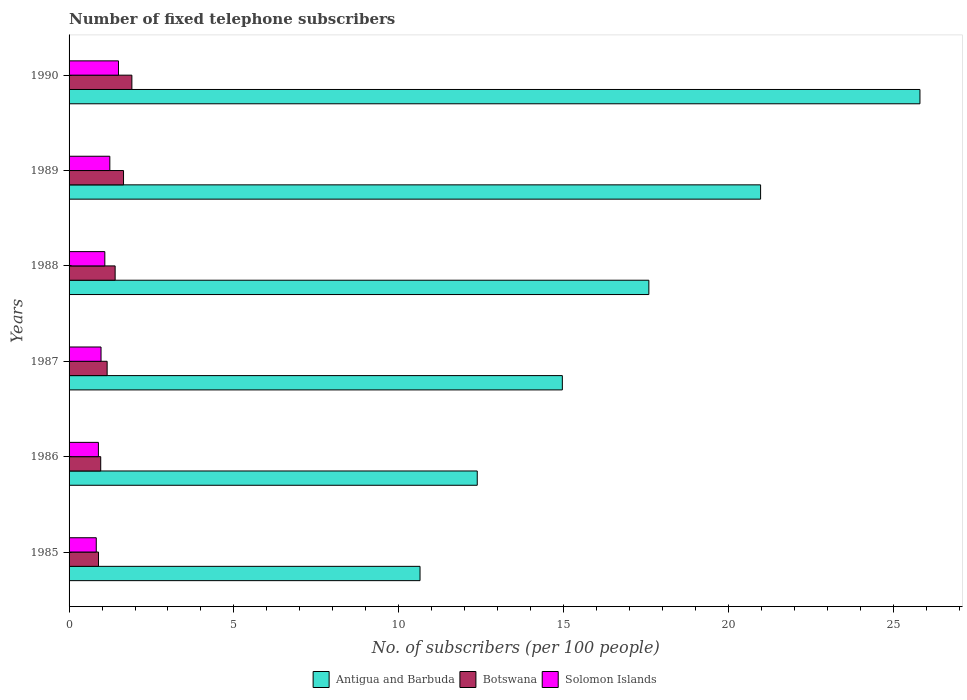How many different coloured bars are there?
Give a very brief answer. 3. How many groups of bars are there?
Your answer should be compact. 6. How many bars are there on the 5th tick from the top?
Your answer should be compact. 3. What is the label of the 4th group of bars from the top?
Your response must be concise. 1987. What is the number of fixed telephone subscribers in Botswana in 1990?
Provide a succinct answer. 1.91. Across all years, what is the maximum number of fixed telephone subscribers in Solomon Islands?
Offer a very short reply. 1.5. Across all years, what is the minimum number of fixed telephone subscribers in Solomon Islands?
Make the answer very short. 0.82. In which year was the number of fixed telephone subscribers in Solomon Islands maximum?
Ensure brevity in your answer.  1990. What is the total number of fixed telephone subscribers in Solomon Islands in the graph?
Keep it short and to the point. 6.51. What is the difference between the number of fixed telephone subscribers in Botswana in 1989 and that in 1990?
Provide a succinct answer. -0.25. What is the difference between the number of fixed telephone subscribers in Solomon Islands in 1987 and the number of fixed telephone subscribers in Botswana in 1985?
Your answer should be compact. 0.08. What is the average number of fixed telephone subscribers in Botswana per year?
Your response must be concise. 1.33. In the year 1985, what is the difference between the number of fixed telephone subscribers in Botswana and number of fixed telephone subscribers in Antigua and Barbuda?
Offer a terse response. -9.75. What is the ratio of the number of fixed telephone subscribers in Antigua and Barbuda in 1988 to that in 1990?
Provide a short and direct response. 0.68. What is the difference between the highest and the second highest number of fixed telephone subscribers in Solomon Islands?
Give a very brief answer. 0.26. What is the difference between the highest and the lowest number of fixed telephone subscribers in Antigua and Barbuda?
Offer a very short reply. 15.17. In how many years, is the number of fixed telephone subscribers in Botswana greater than the average number of fixed telephone subscribers in Botswana taken over all years?
Make the answer very short. 3. What does the 3rd bar from the top in 1986 represents?
Your answer should be compact. Antigua and Barbuda. What does the 2nd bar from the bottom in 1990 represents?
Provide a succinct answer. Botswana. Is it the case that in every year, the sum of the number of fixed telephone subscribers in Antigua and Barbuda and number of fixed telephone subscribers in Botswana is greater than the number of fixed telephone subscribers in Solomon Islands?
Make the answer very short. Yes. How many bars are there?
Keep it short and to the point. 18. How many years are there in the graph?
Your response must be concise. 6. Are the values on the major ticks of X-axis written in scientific E-notation?
Your answer should be compact. No. Where does the legend appear in the graph?
Offer a very short reply. Bottom center. How many legend labels are there?
Your response must be concise. 3. How are the legend labels stacked?
Your answer should be very brief. Horizontal. What is the title of the graph?
Make the answer very short. Number of fixed telephone subscribers. Does "Luxembourg" appear as one of the legend labels in the graph?
Keep it short and to the point. No. What is the label or title of the X-axis?
Your answer should be compact. No. of subscribers (per 100 people). What is the label or title of the Y-axis?
Offer a terse response. Years. What is the No. of subscribers (per 100 people) in Antigua and Barbuda in 1985?
Give a very brief answer. 10.65. What is the No. of subscribers (per 100 people) of Botswana in 1985?
Offer a terse response. 0.89. What is the No. of subscribers (per 100 people) of Solomon Islands in 1985?
Your response must be concise. 0.82. What is the No. of subscribers (per 100 people) in Antigua and Barbuda in 1986?
Provide a succinct answer. 12.38. What is the No. of subscribers (per 100 people) in Botswana in 1986?
Ensure brevity in your answer.  0.96. What is the No. of subscribers (per 100 people) of Solomon Islands in 1986?
Provide a short and direct response. 0.89. What is the No. of subscribers (per 100 people) in Antigua and Barbuda in 1987?
Your answer should be very brief. 14.96. What is the No. of subscribers (per 100 people) of Botswana in 1987?
Provide a succinct answer. 1.16. What is the No. of subscribers (per 100 people) of Solomon Islands in 1987?
Offer a very short reply. 0.97. What is the No. of subscribers (per 100 people) of Antigua and Barbuda in 1988?
Offer a very short reply. 17.59. What is the No. of subscribers (per 100 people) of Botswana in 1988?
Provide a short and direct response. 1.4. What is the No. of subscribers (per 100 people) of Solomon Islands in 1988?
Give a very brief answer. 1.08. What is the No. of subscribers (per 100 people) of Antigua and Barbuda in 1989?
Provide a succinct answer. 20.98. What is the No. of subscribers (per 100 people) in Botswana in 1989?
Make the answer very short. 1.65. What is the No. of subscribers (per 100 people) of Solomon Islands in 1989?
Your response must be concise. 1.24. What is the No. of subscribers (per 100 people) in Antigua and Barbuda in 1990?
Provide a short and direct response. 25.81. What is the No. of subscribers (per 100 people) in Botswana in 1990?
Make the answer very short. 1.91. What is the No. of subscribers (per 100 people) of Solomon Islands in 1990?
Offer a very short reply. 1.5. Across all years, what is the maximum No. of subscribers (per 100 people) of Antigua and Barbuda?
Your response must be concise. 25.81. Across all years, what is the maximum No. of subscribers (per 100 people) of Botswana?
Your answer should be compact. 1.91. Across all years, what is the maximum No. of subscribers (per 100 people) of Solomon Islands?
Your response must be concise. 1.5. Across all years, what is the minimum No. of subscribers (per 100 people) in Antigua and Barbuda?
Offer a very short reply. 10.65. Across all years, what is the minimum No. of subscribers (per 100 people) in Botswana?
Your response must be concise. 0.89. Across all years, what is the minimum No. of subscribers (per 100 people) of Solomon Islands?
Give a very brief answer. 0.82. What is the total No. of subscribers (per 100 people) in Antigua and Barbuda in the graph?
Your answer should be compact. 102.38. What is the total No. of subscribers (per 100 people) in Botswana in the graph?
Ensure brevity in your answer.  7.96. What is the total No. of subscribers (per 100 people) in Solomon Islands in the graph?
Give a very brief answer. 6.51. What is the difference between the No. of subscribers (per 100 people) of Antigua and Barbuda in 1985 and that in 1986?
Your answer should be very brief. -1.74. What is the difference between the No. of subscribers (per 100 people) of Botswana in 1985 and that in 1986?
Your answer should be very brief. -0.07. What is the difference between the No. of subscribers (per 100 people) of Solomon Islands in 1985 and that in 1986?
Your answer should be very brief. -0.07. What is the difference between the No. of subscribers (per 100 people) in Antigua and Barbuda in 1985 and that in 1987?
Give a very brief answer. -4.32. What is the difference between the No. of subscribers (per 100 people) of Botswana in 1985 and that in 1987?
Provide a short and direct response. -0.26. What is the difference between the No. of subscribers (per 100 people) of Solomon Islands in 1985 and that in 1987?
Offer a terse response. -0.14. What is the difference between the No. of subscribers (per 100 people) in Antigua and Barbuda in 1985 and that in 1988?
Ensure brevity in your answer.  -6.94. What is the difference between the No. of subscribers (per 100 people) in Botswana in 1985 and that in 1988?
Keep it short and to the point. -0.51. What is the difference between the No. of subscribers (per 100 people) in Solomon Islands in 1985 and that in 1988?
Keep it short and to the point. -0.26. What is the difference between the No. of subscribers (per 100 people) in Antigua and Barbuda in 1985 and that in 1989?
Your answer should be compact. -10.33. What is the difference between the No. of subscribers (per 100 people) in Botswana in 1985 and that in 1989?
Provide a short and direct response. -0.76. What is the difference between the No. of subscribers (per 100 people) of Solomon Islands in 1985 and that in 1989?
Provide a succinct answer. -0.41. What is the difference between the No. of subscribers (per 100 people) in Antigua and Barbuda in 1985 and that in 1990?
Give a very brief answer. -15.17. What is the difference between the No. of subscribers (per 100 people) of Botswana in 1985 and that in 1990?
Provide a succinct answer. -1.01. What is the difference between the No. of subscribers (per 100 people) in Solomon Islands in 1985 and that in 1990?
Offer a terse response. -0.67. What is the difference between the No. of subscribers (per 100 people) of Antigua and Barbuda in 1986 and that in 1987?
Provide a succinct answer. -2.58. What is the difference between the No. of subscribers (per 100 people) of Botswana in 1986 and that in 1987?
Give a very brief answer. -0.19. What is the difference between the No. of subscribers (per 100 people) of Solomon Islands in 1986 and that in 1987?
Provide a short and direct response. -0.08. What is the difference between the No. of subscribers (per 100 people) in Antigua and Barbuda in 1986 and that in 1988?
Give a very brief answer. -5.21. What is the difference between the No. of subscribers (per 100 people) of Botswana in 1986 and that in 1988?
Provide a succinct answer. -0.44. What is the difference between the No. of subscribers (per 100 people) in Solomon Islands in 1986 and that in 1988?
Ensure brevity in your answer.  -0.19. What is the difference between the No. of subscribers (per 100 people) in Antigua and Barbuda in 1986 and that in 1989?
Ensure brevity in your answer.  -8.6. What is the difference between the No. of subscribers (per 100 people) in Botswana in 1986 and that in 1989?
Your answer should be compact. -0.69. What is the difference between the No. of subscribers (per 100 people) in Solomon Islands in 1986 and that in 1989?
Offer a terse response. -0.35. What is the difference between the No. of subscribers (per 100 people) of Antigua and Barbuda in 1986 and that in 1990?
Give a very brief answer. -13.43. What is the difference between the No. of subscribers (per 100 people) in Botswana in 1986 and that in 1990?
Your response must be concise. -0.94. What is the difference between the No. of subscribers (per 100 people) of Solomon Islands in 1986 and that in 1990?
Provide a short and direct response. -0.61. What is the difference between the No. of subscribers (per 100 people) in Antigua and Barbuda in 1987 and that in 1988?
Offer a terse response. -2.62. What is the difference between the No. of subscribers (per 100 people) of Botswana in 1987 and that in 1988?
Make the answer very short. -0.24. What is the difference between the No. of subscribers (per 100 people) in Solomon Islands in 1987 and that in 1988?
Ensure brevity in your answer.  -0.12. What is the difference between the No. of subscribers (per 100 people) of Antigua and Barbuda in 1987 and that in 1989?
Provide a short and direct response. -6.01. What is the difference between the No. of subscribers (per 100 people) of Botswana in 1987 and that in 1989?
Make the answer very short. -0.5. What is the difference between the No. of subscribers (per 100 people) in Solomon Islands in 1987 and that in 1989?
Keep it short and to the point. -0.27. What is the difference between the No. of subscribers (per 100 people) in Antigua and Barbuda in 1987 and that in 1990?
Offer a very short reply. -10.85. What is the difference between the No. of subscribers (per 100 people) in Botswana in 1987 and that in 1990?
Ensure brevity in your answer.  -0.75. What is the difference between the No. of subscribers (per 100 people) of Solomon Islands in 1987 and that in 1990?
Your answer should be compact. -0.53. What is the difference between the No. of subscribers (per 100 people) of Antigua and Barbuda in 1988 and that in 1989?
Give a very brief answer. -3.39. What is the difference between the No. of subscribers (per 100 people) in Botswana in 1988 and that in 1989?
Make the answer very short. -0.25. What is the difference between the No. of subscribers (per 100 people) of Solomon Islands in 1988 and that in 1989?
Ensure brevity in your answer.  -0.15. What is the difference between the No. of subscribers (per 100 people) of Antigua and Barbuda in 1988 and that in 1990?
Provide a short and direct response. -8.22. What is the difference between the No. of subscribers (per 100 people) in Botswana in 1988 and that in 1990?
Offer a terse response. -0.51. What is the difference between the No. of subscribers (per 100 people) in Solomon Islands in 1988 and that in 1990?
Your response must be concise. -0.41. What is the difference between the No. of subscribers (per 100 people) of Antigua and Barbuda in 1989 and that in 1990?
Keep it short and to the point. -4.83. What is the difference between the No. of subscribers (per 100 people) in Botswana in 1989 and that in 1990?
Provide a short and direct response. -0.25. What is the difference between the No. of subscribers (per 100 people) of Solomon Islands in 1989 and that in 1990?
Make the answer very short. -0.26. What is the difference between the No. of subscribers (per 100 people) of Antigua and Barbuda in 1985 and the No. of subscribers (per 100 people) of Botswana in 1986?
Provide a succinct answer. 9.69. What is the difference between the No. of subscribers (per 100 people) of Antigua and Barbuda in 1985 and the No. of subscribers (per 100 people) of Solomon Islands in 1986?
Offer a very short reply. 9.76. What is the difference between the No. of subscribers (per 100 people) in Botswana in 1985 and the No. of subscribers (per 100 people) in Solomon Islands in 1986?
Offer a terse response. 0. What is the difference between the No. of subscribers (per 100 people) of Antigua and Barbuda in 1985 and the No. of subscribers (per 100 people) of Botswana in 1987?
Offer a terse response. 9.49. What is the difference between the No. of subscribers (per 100 people) of Antigua and Barbuda in 1985 and the No. of subscribers (per 100 people) of Solomon Islands in 1987?
Your answer should be very brief. 9.68. What is the difference between the No. of subscribers (per 100 people) in Botswana in 1985 and the No. of subscribers (per 100 people) in Solomon Islands in 1987?
Your answer should be compact. -0.08. What is the difference between the No. of subscribers (per 100 people) in Antigua and Barbuda in 1985 and the No. of subscribers (per 100 people) in Botswana in 1988?
Provide a short and direct response. 9.25. What is the difference between the No. of subscribers (per 100 people) in Antigua and Barbuda in 1985 and the No. of subscribers (per 100 people) in Solomon Islands in 1988?
Your answer should be compact. 9.56. What is the difference between the No. of subscribers (per 100 people) of Botswana in 1985 and the No. of subscribers (per 100 people) of Solomon Islands in 1988?
Provide a succinct answer. -0.19. What is the difference between the No. of subscribers (per 100 people) in Antigua and Barbuda in 1985 and the No. of subscribers (per 100 people) in Botswana in 1989?
Provide a short and direct response. 9. What is the difference between the No. of subscribers (per 100 people) of Antigua and Barbuda in 1985 and the No. of subscribers (per 100 people) of Solomon Islands in 1989?
Your response must be concise. 9.41. What is the difference between the No. of subscribers (per 100 people) of Botswana in 1985 and the No. of subscribers (per 100 people) of Solomon Islands in 1989?
Offer a terse response. -0.34. What is the difference between the No. of subscribers (per 100 people) of Antigua and Barbuda in 1985 and the No. of subscribers (per 100 people) of Botswana in 1990?
Your answer should be compact. 8.74. What is the difference between the No. of subscribers (per 100 people) in Antigua and Barbuda in 1985 and the No. of subscribers (per 100 people) in Solomon Islands in 1990?
Ensure brevity in your answer.  9.15. What is the difference between the No. of subscribers (per 100 people) in Botswana in 1985 and the No. of subscribers (per 100 people) in Solomon Islands in 1990?
Provide a short and direct response. -0.61. What is the difference between the No. of subscribers (per 100 people) in Antigua and Barbuda in 1986 and the No. of subscribers (per 100 people) in Botswana in 1987?
Ensure brevity in your answer.  11.23. What is the difference between the No. of subscribers (per 100 people) in Antigua and Barbuda in 1986 and the No. of subscribers (per 100 people) in Solomon Islands in 1987?
Ensure brevity in your answer.  11.41. What is the difference between the No. of subscribers (per 100 people) of Botswana in 1986 and the No. of subscribers (per 100 people) of Solomon Islands in 1987?
Provide a short and direct response. -0.01. What is the difference between the No. of subscribers (per 100 people) of Antigua and Barbuda in 1986 and the No. of subscribers (per 100 people) of Botswana in 1988?
Offer a terse response. 10.99. What is the difference between the No. of subscribers (per 100 people) of Antigua and Barbuda in 1986 and the No. of subscribers (per 100 people) of Solomon Islands in 1988?
Your answer should be compact. 11.3. What is the difference between the No. of subscribers (per 100 people) in Botswana in 1986 and the No. of subscribers (per 100 people) in Solomon Islands in 1988?
Offer a very short reply. -0.12. What is the difference between the No. of subscribers (per 100 people) of Antigua and Barbuda in 1986 and the No. of subscribers (per 100 people) of Botswana in 1989?
Offer a terse response. 10.73. What is the difference between the No. of subscribers (per 100 people) of Antigua and Barbuda in 1986 and the No. of subscribers (per 100 people) of Solomon Islands in 1989?
Offer a terse response. 11.15. What is the difference between the No. of subscribers (per 100 people) of Botswana in 1986 and the No. of subscribers (per 100 people) of Solomon Islands in 1989?
Provide a succinct answer. -0.28. What is the difference between the No. of subscribers (per 100 people) of Antigua and Barbuda in 1986 and the No. of subscribers (per 100 people) of Botswana in 1990?
Your answer should be compact. 10.48. What is the difference between the No. of subscribers (per 100 people) in Antigua and Barbuda in 1986 and the No. of subscribers (per 100 people) in Solomon Islands in 1990?
Your answer should be compact. 10.88. What is the difference between the No. of subscribers (per 100 people) of Botswana in 1986 and the No. of subscribers (per 100 people) of Solomon Islands in 1990?
Provide a short and direct response. -0.54. What is the difference between the No. of subscribers (per 100 people) of Antigua and Barbuda in 1987 and the No. of subscribers (per 100 people) of Botswana in 1988?
Your response must be concise. 13.57. What is the difference between the No. of subscribers (per 100 people) in Antigua and Barbuda in 1987 and the No. of subscribers (per 100 people) in Solomon Islands in 1988?
Your answer should be compact. 13.88. What is the difference between the No. of subscribers (per 100 people) of Botswana in 1987 and the No. of subscribers (per 100 people) of Solomon Islands in 1988?
Keep it short and to the point. 0.07. What is the difference between the No. of subscribers (per 100 people) in Antigua and Barbuda in 1987 and the No. of subscribers (per 100 people) in Botswana in 1989?
Give a very brief answer. 13.31. What is the difference between the No. of subscribers (per 100 people) of Antigua and Barbuda in 1987 and the No. of subscribers (per 100 people) of Solomon Islands in 1989?
Your answer should be compact. 13.73. What is the difference between the No. of subscribers (per 100 people) in Botswana in 1987 and the No. of subscribers (per 100 people) in Solomon Islands in 1989?
Make the answer very short. -0.08. What is the difference between the No. of subscribers (per 100 people) in Antigua and Barbuda in 1987 and the No. of subscribers (per 100 people) in Botswana in 1990?
Ensure brevity in your answer.  13.06. What is the difference between the No. of subscribers (per 100 people) in Antigua and Barbuda in 1987 and the No. of subscribers (per 100 people) in Solomon Islands in 1990?
Keep it short and to the point. 13.47. What is the difference between the No. of subscribers (per 100 people) of Botswana in 1987 and the No. of subscribers (per 100 people) of Solomon Islands in 1990?
Your answer should be compact. -0.34. What is the difference between the No. of subscribers (per 100 people) in Antigua and Barbuda in 1988 and the No. of subscribers (per 100 people) in Botswana in 1989?
Keep it short and to the point. 15.94. What is the difference between the No. of subscribers (per 100 people) in Antigua and Barbuda in 1988 and the No. of subscribers (per 100 people) in Solomon Islands in 1989?
Keep it short and to the point. 16.35. What is the difference between the No. of subscribers (per 100 people) in Botswana in 1988 and the No. of subscribers (per 100 people) in Solomon Islands in 1989?
Make the answer very short. 0.16. What is the difference between the No. of subscribers (per 100 people) of Antigua and Barbuda in 1988 and the No. of subscribers (per 100 people) of Botswana in 1990?
Give a very brief answer. 15.68. What is the difference between the No. of subscribers (per 100 people) of Antigua and Barbuda in 1988 and the No. of subscribers (per 100 people) of Solomon Islands in 1990?
Give a very brief answer. 16.09. What is the difference between the No. of subscribers (per 100 people) of Botswana in 1988 and the No. of subscribers (per 100 people) of Solomon Islands in 1990?
Offer a terse response. -0.1. What is the difference between the No. of subscribers (per 100 people) in Antigua and Barbuda in 1989 and the No. of subscribers (per 100 people) in Botswana in 1990?
Make the answer very short. 19.07. What is the difference between the No. of subscribers (per 100 people) in Antigua and Barbuda in 1989 and the No. of subscribers (per 100 people) in Solomon Islands in 1990?
Provide a succinct answer. 19.48. What is the difference between the No. of subscribers (per 100 people) in Botswana in 1989 and the No. of subscribers (per 100 people) in Solomon Islands in 1990?
Provide a succinct answer. 0.15. What is the average No. of subscribers (per 100 people) in Antigua and Barbuda per year?
Your response must be concise. 17.06. What is the average No. of subscribers (per 100 people) of Botswana per year?
Offer a very short reply. 1.33. What is the average No. of subscribers (per 100 people) in Solomon Islands per year?
Make the answer very short. 1.08. In the year 1985, what is the difference between the No. of subscribers (per 100 people) in Antigua and Barbuda and No. of subscribers (per 100 people) in Botswana?
Your answer should be compact. 9.75. In the year 1985, what is the difference between the No. of subscribers (per 100 people) in Antigua and Barbuda and No. of subscribers (per 100 people) in Solomon Islands?
Give a very brief answer. 9.82. In the year 1985, what is the difference between the No. of subscribers (per 100 people) of Botswana and No. of subscribers (per 100 people) of Solomon Islands?
Offer a terse response. 0.07. In the year 1986, what is the difference between the No. of subscribers (per 100 people) of Antigua and Barbuda and No. of subscribers (per 100 people) of Botswana?
Provide a short and direct response. 11.42. In the year 1986, what is the difference between the No. of subscribers (per 100 people) in Antigua and Barbuda and No. of subscribers (per 100 people) in Solomon Islands?
Offer a terse response. 11.49. In the year 1986, what is the difference between the No. of subscribers (per 100 people) in Botswana and No. of subscribers (per 100 people) in Solomon Islands?
Ensure brevity in your answer.  0.07. In the year 1987, what is the difference between the No. of subscribers (per 100 people) of Antigua and Barbuda and No. of subscribers (per 100 people) of Botswana?
Give a very brief answer. 13.81. In the year 1987, what is the difference between the No. of subscribers (per 100 people) of Antigua and Barbuda and No. of subscribers (per 100 people) of Solomon Islands?
Your answer should be compact. 13.99. In the year 1987, what is the difference between the No. of subscribers (per 100 people) in Botswana and No. of subscribers (per 100 people) in Solomon Islands?
Provide a succinct answer. 0.19. In the year 1988, what is the difference between the No. of subscribers (per 100 people) of Antigua and Barbuda and No. of subscribers (per 100 people) of Botswana?
Your answer should be very brief. 16.19. In the year 1988, what is the difference between the No. of subscribers (per 100 people) in Antigua and Barbuda and No. of subscribers (per 100 people) in Solomon Islands?
Ensure brevity in your answer.  16.5. In the year 1988, what is the difference between the No. of subscribers (per 100 people) in Botswana and No. of subscribers (per 100 people) in Solomon Islands?
Provide a short and direct response. 0.31. In the year 1989, what is the difference between the No. of subscribers (per 100 people) of Antigua and Barbuda and No. of subscribers (per 100 people) of Botswana?
Your answer should be very brief. 19.33. In the year 1989, what is the difference between the No. of subscribers (per 100 people) of Antigua and Barbuda and No. of subscribers (per 100 people) of Solomon Islands?
Provide a succinct answer. 19.74. In the year 1989, what is the difference between the No. of subscribers (per 100 people) of Botswana and No. of subscribers (per 100 people) of Solomon Islands?
Ensure brevity in your answer.  0.42. In the year 1990, what is the difference between the No. of subscribers (per 100 people) in Antigua and Barbuda and No. of subscribers (per 100 people) in Botswana?
Provide a short and direct response. 23.91. In the year 1990, what is the difference between the No. of subscribers (per 100 people) in Antigua and Barbuda and No. of subscribers (per 100 people) in Solomon Islands?
Ensure brevity in your answer.  24.31. In the year 1990, what is the difference between the No. of subscribers (per 100 people) in Botswana and No. of subscribers (per 100 people) in Solomon Islands?
Ensure brevity in your answer.  0.41. What is the ratio of the No. of subscribers (per 100 people) in Antigua and Barbuda in 1985 to that in 1986?
Offer a terse response. 0.86. What is the ratio of the No. of subscribers (per 100 people) in Botswana in 1985 to that in 1986?
Provide a short and direct response. 0.93. What is the ratio of the No. of subscribers (per 100 people) of Solomon Islands in 1985 to that in 1986?
Provide a succinct answer. 0.93. What is the ratio of the No. of subscribers (per 100 people) in Antigua and Barbuda in 1985 to that in 1987?
Provide a short and direct response. 0.71. What is the ratio of the No. of subscribers (per 100 people) of Botswana in 1985 to that in 1987?
Make the answer very short. 0.77. What is the ratio of the No. of subscribers (per 100 people) in Solomon Islands in 1985 to that in 1987?
Your response must be concise. 0.85. What is the ratio of the No. of subscribers (per 100 people) of Antigua and Barbuda in 1985 to that in 1988?
Offer a terse response. 0.61. What is the ratio of the No. of subscribers (per 100 people) in Botswana in 1985 to that in 1988?
Your response must be concise. 0.64. What is the ratio of the No. of subscribers (per 100 people) in Solomon Islands in 1985 to that in 1988?
Provide a succinct answer. 0.76. What is the ratio of the No. of subscribers (per 100 people) of Antigua and Barbuda in 1985 to that in 1989?
Your answer should be very brief. 0.51. What is the ratio of the No. of subscribers (per 100 people) of Botswana in 1985 to that in 1989?
Offer a very short reply. 0.54. What is the ratio of the No. of subscribers (per 100 people) in Solomon Islands in 1985 to that in 1989?
Give a very brief answer. 0.67. What is the ratio of the No. of subscribers (per 100 people) in Antigua and Barbuda in 1985 to that in 1990?
Ensure brevity in your answer.  0.41. What is the ratio of the No. of subscribers (per 100 people) in Botswana in 1985 to that in 1990?
Ensure brevity in your answer.  0.47. What is the ratio of the No. of subscribers (per 100 people) of Solomon Islands in 1985 to that in 1990?
Offer a very short reply. 0.55. What is the ratio of the No. of subscribers (per 100 people) in Antigua and Barbuda in 1986 to that in 1987?
Provide a succinct answer. 0.83. What is the ratio of the No. of subscribers (per 100 people) in Botswana in 1986 to that in 1987?
Offer a very short reply. 0.83. What is the ratio of the No. of subscribers (per 100 people) in Solomon Islands in 1986 to that in 1987?
Make the answer very short. 0.92. What is the ratio of the No. of subscribers (per 100 people) of Antigua and Barbuda in 1986 to that in 1988?
Your answer should be compact. 0.7. What is the ratio of the No. of subscribers (per 100 people) in Botswana in 1986 to that in 1988?
Offer a terse response. 0.69. What is the ratio of the No. of subscribers (per 100 people) of Solomon Islands in 1986 to that in 1988?
Ensure brevity in your answer.  0.82. What is the ratio of the No. of subscribers (per 100 people) in Antigua and Barbuda in 1986 to that in 1989?
Ensure brevity in your answer.  0.59. What is the ratio of the No. of subscribers (per 100 people) in Botswana in 1986 to that in 1989?
Provide a short and direct response. 0.58. What is the ratio of the No. of subscribers (per 100 people) of Solomon Islands in 1986 to that in 1989?
Provide a succinct answer. 0.72. What is the ratio of the No. of subscribers (per 100 people) of Antigua and Barbuda in 1986 to that in 1990?
Your response must be concise. 0.48. What is the ratio of the No. of subscribers (per 100 people) in Botswana in 1986 to that in 1990?
Ensure brevity in your answer.  0.5. What is the ratio of the No. of subscribers (per 100 people) in Solomon Islands in 1986 to that in 1990?
Offer a terse response. 0.59. What is the ratio of the No. of subscribers (per 100 people) of Antigua and Barbuda in 1987 to that in 1988?
Ensure brevity in your answer.  0.85. What is the ratio of the No. of subscribers (per 100 people) of Botswana in 1987 to that in 1988?
Give a very brief answer. 0.83. What is the ratio of the No. of subscribers (per 100 people) of Solomon Islands in 1987 to that in 1988?
Offer a terse response. 0.89. What is the ratio of the No. of subscribers (per 100 people) in Antigua and Barbuda in 1987 to that in 1989?
Offer a very short reply. 0.71. What is the ratio of the No. of subscribers (per 100 people) of Botswana in 1987 to that in 1989?
Provide a succinct answer. 0.7. What is the ratio of the No. of subscribers (per 100 people) of Solomon Islands in 1987 to that in 1989?
Offer a terse response. 0.78. What is the ratio of the No. of subscribers (per 100 people) of Antigua and Barbuda in 1987 to that in 1990?
Give a very brief answer. 0.58. What is the ratio of the No. of subscribers (per 100 people) in Botswana in 1987 to that in 1990?
Your answer should be very brief. 0.61. What is the ratio of the No. of subscribers (per 100 people) of Solomon Islands in 1987 to that in 1990?
Your answer should be compact. 0.65. What is the ratio of the No. of subscribers (per 100 people) of Antigua and Barbuda in 1988 to that in 1989?
Your response must be concise. 0.84. What is the ratio of the No. of subscribers (per 100 people) in Botswana in 1988 to that in 1989?
Give a very brief answer. 0.85. What is the ratio of the No. of subscribers (per 100 people) in Solomon Islands in 1988 to that in 1989?
Ensure brevity in your answer.  0.88. What is the ratio of the No. of subscribers (per 100 people) of Antigua and Barbuda in 1988 to that in 1990?
Offer a terse response. 0.68. What is the ratio of the No. of subscribers (per 100 people) of Botswana in 1988 to that in 1990?
Make the answer very short. 0.73. What is the ratio of the No. of subscribers (per 100 people) in Solomon Islands in 1988 to that in 1990?
Make the answer very short. 0.72. What is the ratio of the No. of subscribers (per 100 people) in Antigua and Barbuda in 1989 to that in 1990?
Provide a succinct answer. 0.81. What is the ratio of the No. of subscribers (per 100 people) in Botswana in 1989 to that in 1990?
Your answer should be compact. 0.87. What is the ratio of the No. of subscribers (per 100 people) in Solomon Islands in 1989 to that in 1990?
Your response must be concise. 0.82. What is the difference between the highest and the second highest No. of subscribers (per 100 people) of Antigua and Barbuda?
Give a very brief answer. 4.83. What is the difference between the highest and the second highest No. of subscribers (per 100 people) of Botswana?
Offer a terse response. 0.25. What is the difference between the highest and the second highest No. of subscribers (per 100 people) of Solomon Islands?
Your answer should be very brief. 0.26. What is the difference between the highest and the lowest No. of subscribers (per 100 people) in Antigua and Barbuda?
Offer a very short reply. 15.17. What is the difference between the highest and the lowest No. of subscribers (per 100 people) in Botswana?
Make the answer very short. 1.01. What is the difference between the highest and the lowest No. of subscribers (per 100 people) in Solomon Islands?
Your answer should be compact. 0.67. 